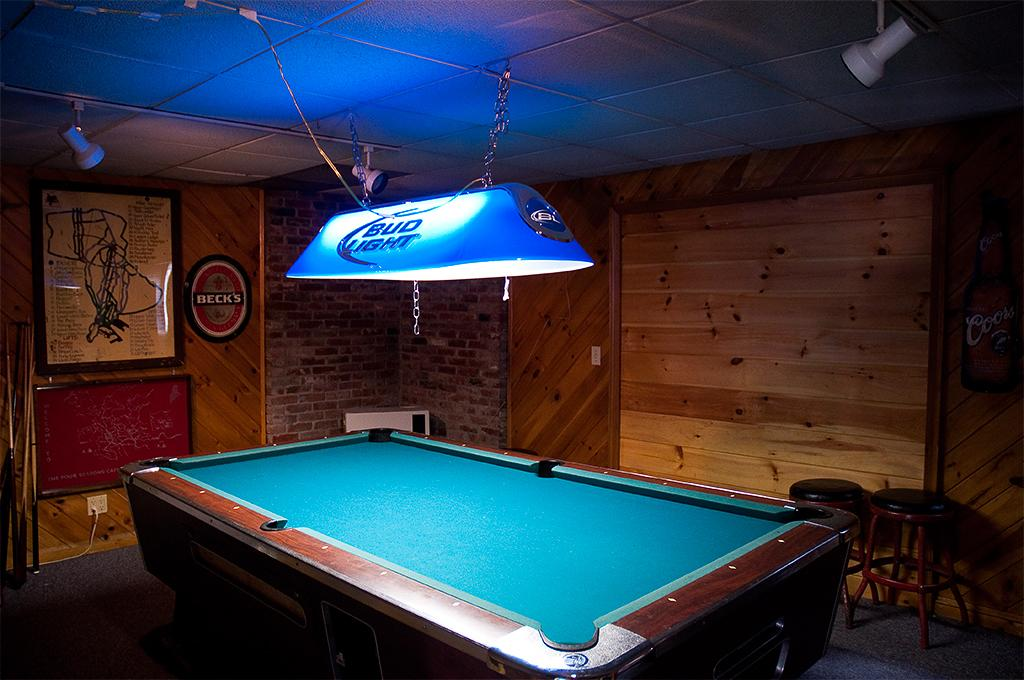What can be seen in the background of the image? There is a board in the background of the image. What type of material is used for the wall at the top of the image? The wall at the top of the image is made of wood. Can you describe the lighting in the image? There is a light visible in the image. What condition does the actor have in the picture? There is no actor present in the image, so it is not possible to determine any condition they might have. 